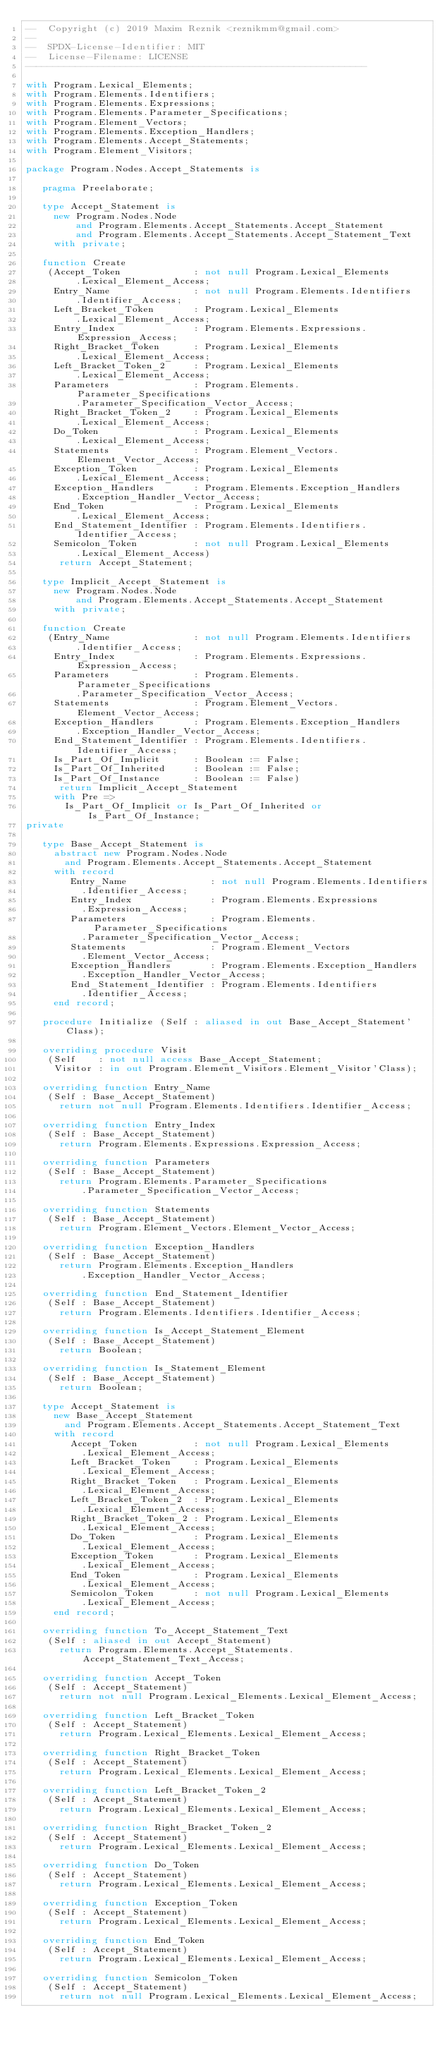Convert code to text. <code><loc_0><loc_0><loc_500><loc_500><_Ada_>--  Copyright (c) 2019 Maxim Reznik <reznikmm@gmail.com>
--
--  SPDX-License-Identifier: MIT
--  License-Filename: LICENSE
-------------------------------------------------------------

with Program.Lexical_Elements;
with Program.Elements.Identifiers;
with Program.Elements.Expressions;
with Program.Elements.Parameter_Specifications;
with Program.Element_Vectors;
with Program.Elements.Exception_Handlers;
with Program.Elements.Accept_Statements;
with Program.Element_Visitors;

package Program.Nodes.Accept_Statements is

   pragma Preelaborate;

   type Accept_Statement is
     new Program.Nodes.Node
         and Program.Elements.Accept_Statements.Accept_Statement
         and Program.Elements.Accept_Statements.Accept_Statement_Text
     with private;

   function Create
    (Accept_Token             : not null Program.Lexical_Elements
         .Lexical_Element_Access;
     Entry_Name               : not null Program.Elements.Identifiers
         .Identifier_Access;
     Left_Bracket_Token       : Program.Lexical_Elements
         .Lexical_Element_Access;
     Entry_Index              : Program.Elements.Expressions.Expression_Access;
     Right_Bracket_Token      : Program.Lexical_Elements
         .Lexical_Element_Access;
     Left_Bracket_Token_2     : Program.Lexical_Elements
         .Lexical_Element_Access;
     Parameters               : Program.Elements.Parameter_Specifications
         .Parameter_Specification_Vector_Access;
     Right_Bracket_Token_2    : Program.Lexical_Elements
         .Lexical_Element_Access;
     Do_Token                 : Program.Lexical_Elements
         .Lexical_Element_Access;
     Statements               : Program.Element_Vectors.Element_Vector_Access;
     Exception_Token          : Program.Lexical_Elements
         .Lexical_Element_Access;
     Exception_Handlers       : Program.Elements.Exception_Handlers
         .Exception_Handler_Vector_Access;
     End_Token                : Program.Lexical_Elements
         .Lexical_Element_Access;
     End_Statement_Identifier : Program.Elements.Identifiers.Identifier_Access;
     Semicolon_Token          : not null Program.Lexical_Elements
         .Lexical_Element_Access)
      return Accept_Statement;

   type Implicit_Accept_Statement is
     new Program.Nodes.Node
         and Program.Elements.Accept_Statements.Accept_Statement
     with private;

   function Create
    (Entry_Name               : not null Program.Elements.Identifiers
         .Identifier_Access;
     Entry_Index              : Program.Elements.Expressions.Expression_Access;
     Parameters               : Program.Elements.Parameter_Specifications
         .Parameter_Specification_Vector_Access;
     Statements               : Program.Element_Vectors.Element_Vector_Access;
     Exception_Handlers       : Program.Elements.Exception_Handlers
         .Exception_Handler_Vector_Access;
     End_Statement_Identifier : Program.Elements.Identifiers.Identifier_Access;
     Is_Part_Of_Implicit      : Boolean := False;
     Is_Part_Of_Inherited     : Boolean := False;
     Is_Part_Of_Instance      : Boolean := False)
      return Implicit_Accept_Statement
     with Pre =>
       Is_Part_Of_Implicit or Is_Part_Of_Inherited or Is_Part_Of_Instance;
private

   type Base_Accept_Statement is
     abstract new Program.Nodes.Node
       and Program.Elements.Accept_Statements.Accept_Statement
     with record
        Entry_Name               : not null Program.Elements.Identifiers
          .Identifier_Access;
        Entry_Index              : Program.Elements.Expressions
          .Expression_Access;
        Parameters               : Program.Elements.Parameter_Specifications
          .Parameter_Specification_Vector_Access;
        Statements               : Program.Element_Vectors
          .Element_Vector_Access;
        Exception_Handlers       : Program.Elements.Exception_Handlers
          .Exception_Handler_Vector_Access;
        End_Statement_Identifier : Program.Elements.Identifiers
          .Identifier_Access;
     end record;

   procedure Initialize (Self : aliased in out Base_Accept_Statement'Class);

   overriding procedure Visit
    (Self    : not null access Base_Accept_Statement;
     Visitor : in out Program.Element_Visitors.Element_Visitor'Class);

   overriding function Entry_Name
    (Self : Base_Accept_Statement)
      return not null Program.Elements.Identifiers.Identifier_Access;

   overriding function Entry_Index
    (Self : Base_Accept_Statement)
      return Program.Elements.Expressions.Expression_Access;

   overriding function Parameters
    (Self : Base_Accept_Statement)
      return Program.Elements.Parameter_Specifications
          .Parameter_Specification_Vector_Access;

   overriding function Statements
    (Self : Base_Accept_Statement)
      return Program.Element_Vectors.Element_Vector_Access;

   overriding function Exception_Handlers
    (Self : Base_Accept_Statement)
      return Program.Elements.Exception_Handlers
          .Exception_Handler_Vector_Access;

   overriding function End_Statement_Identifier
    (Self : Base_Accept_Statement)
      return Program.Elements.Identifiers.Identifier_Access;

   overriding function Is_Accept_Statement_Element
    (Self : Base_Accept_Statement)
      return Boolean;

   overriding function Is_Statement_Element
    (Self : Base_Accept_Statement)
      return Boolean;

   type Accept_Statement is
     new Base_Accept_Statement
       and Program.Elements.Accept_Statements.Accept_Statement_Text
     with record
        Accept_Token          : not null Program.Lexical_Elements
          .Lexical_Element_Access;
        Left_Bracket_Token    : Program.Lexical_Elements
          .Lexical_Element_Access;
        Right_Bracket_Token   : Program.Lexical_Elements
          .Lexical_Element_Access;
        Left_Bracket_Token_2  : Program.Lexical_Elements
          .Lexical_Element_Access;
        Right_Bracket_Token_2 : Program.Lexical_Elements
          .Lexical_Element_Access;
        Do_Token              : Program.Lexical_Elements
          .Lexical_Element_Access;
        Exception_Token       : Program.Lexical_Elements
          .Lexical_Element_Access;
        End_Token             : Program.Lexical_Elements
          .Lexical_Element_Access;
        Semicolon_Token       : not null Program.Lexical_Elements
          .Lexical_Element_Access;
     end record;

   overriding function To_Accept_Statement_Text
    (Self : aliased in out Accept_Statement)
      return Program.Elements.Accept_Statements.Accept_Statement_Text_Access;

   overriding function Accept_Token
    (Self : Accept_Statement)
      return not null Program.Lexical_Elements.Lexical_Element_Access;

   overriding function Left_Bracket_Token
    (Self : Accept_Statement)
      return Program.Lexical_Elements.Lexical_Element_Access;

   overriding function Right_Bracket_Token
    (Self : Accept_Statement)
      return Program.Lexical_Elements.Lexical_Element_Access;

   overriding function Left_Bracket_Token_2
    (Self : Accept_Statement)
      return Program.Lexical_Elements.Lexical_Element_Access;

   overriding function Right_Bracket_Token_2
    (Self : Accept_Statement)
      return Program.Lexical_Elements.Lexical_Element_Access;

   overriding function Do_Token
    (Self : Accept_Statement)
      return Program.Lexical_Elements.Lexical_Element_Access;

   overriding function Exception_Token
    (Self : Accept_Statement)
      return Program.Lexical_Elements.Lexical_Element_Access;

   overriding function End_Token
    (Self : Accept_Statement)
      return Program.Lexical_Elements.Lexical_Element_Access;

   overriding function Semicolon_Token
    (Self : Accept_Statement)
      return not null Program.Lexical_Elements.Lexical_Element_Access;
</code> 